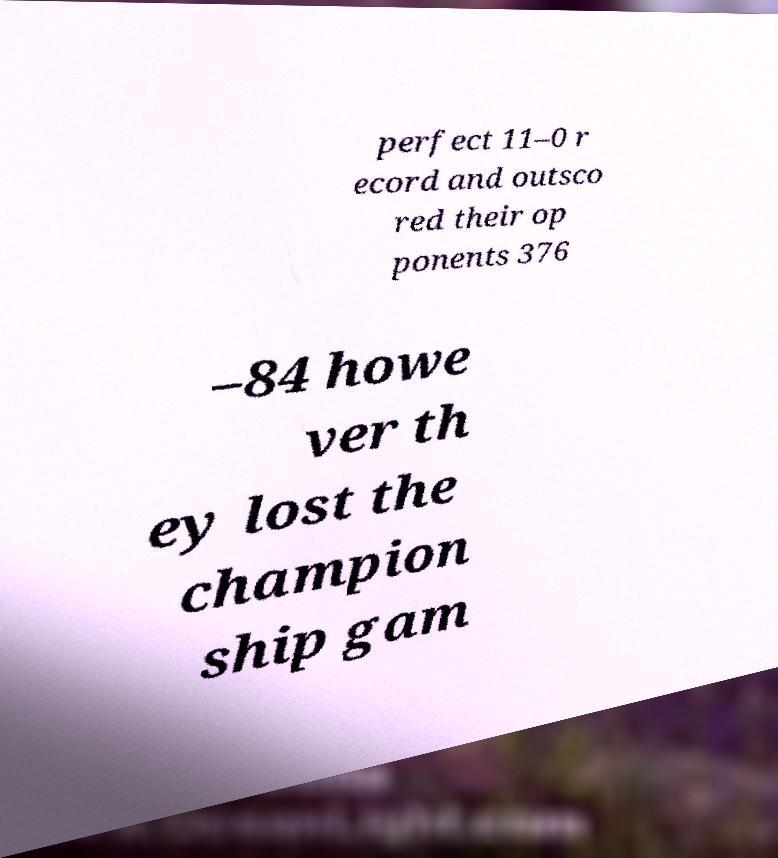Please read and relay the text visible in this image. What does it say? perfect 11–0 r ecord and outsco red their op ponents 376 –84 howe ver th ey lost the champion ship gam 